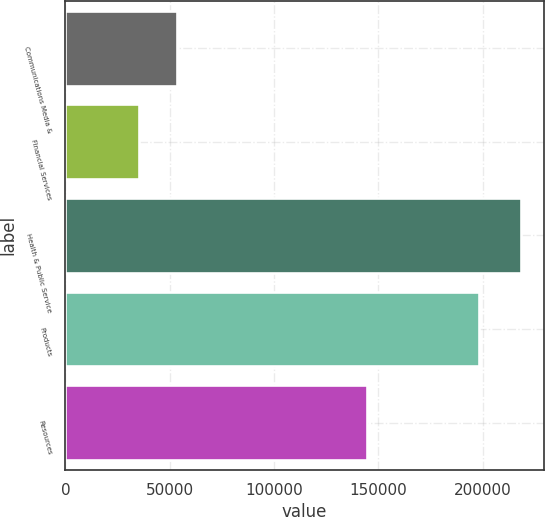<chart> <loc_0><loc_0><loc_500><loc_500><bar_chart><fcel>Communications Media &<fcel>Financial Services<fcel>Health & Public Service<fcel>Products<fcel>Resources<nl><fcel>53400.1<fcel>35060<fcel>218461<fcel>198274<fcel>144844<nl></chart> 